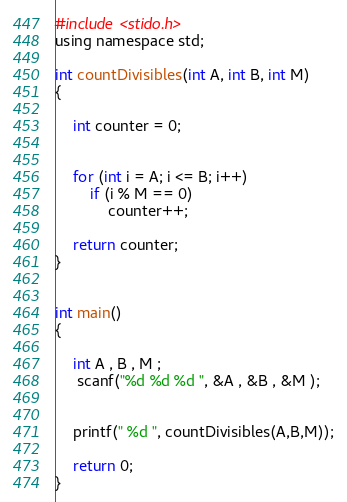Convert code to text. <code><loc_0><loc_0><loc_500><loc_500><_C_>#include <stido.h>
using namespace std;

int countDivisibles(int A, int B, int M)
{

    int counter = 0;


    for (int i = A; i <= B; i++)
        if (i % M == 0)
            counter++;

    return counter;
}


int main()
{

    int A , B , M ;
     scanf("%d %d %d ", &A , &B , &M );


    printf(" %d ", countDivisibles(A,B,M));

    return 0;
}
</code> 